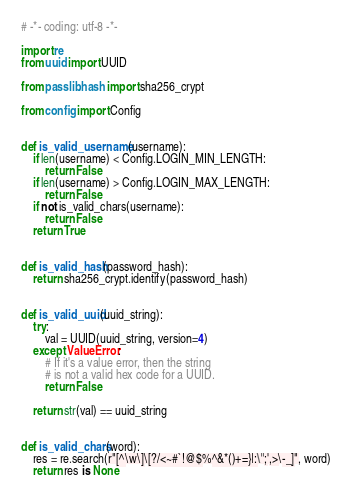<code> <loc_0><loc_0><loc_500><loc_500><_Python_># -*- coding: utf-8 -*-

import re
from uuid import UUID

from passlib.hash import sha256_crypt

from config import Config


def is_valid_username(username):
    if len(username) < Config.LOGIN_MIN_LENGTH:
        return False
    if len(username) > Config.LOGIN_MAX_LENGTH:
        return False
    if not is_valid_chars(username):
        return False
    return True


def is_valid_hash(password_hash):
    return sha256_crypt.identify(password_hash)


def is_valid_uuid(uuid_string):
    try:
        val = UUID(uuid_string, version=4)
    except ValueError:
        # If it's a value error, then the string
        # is not a valid hex code for a UUID.
        return False

    return str(val) == uuid_string


def is_valid_chars(word):
    res = re.search(r"[^\w\]\[?/<~#`!@$%^&*()+=}|:\";',>\-_]", word)
    return res is None
</code> 